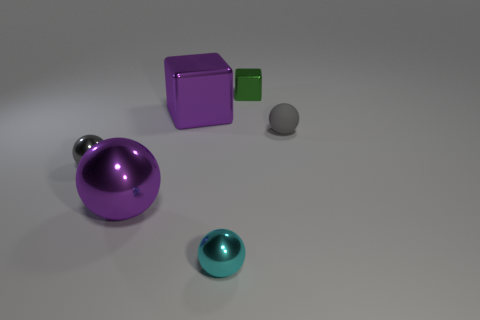Subtract 1 balls. How many balls are left? 3 Add 3 small green metal things. How many objects exist? 9 Subtract all cubes. How many objects are left? 4 Add 5 small green objects. How many small green objects are left? 6 Add 3 large purple shiny blocks. How many large purple shiny blocks exist? 4 Subtract 0 cyan cylinders. How many objects are left? 6 Subtract all purple spheres. Subtract all gray things. How many objects are left? 3 